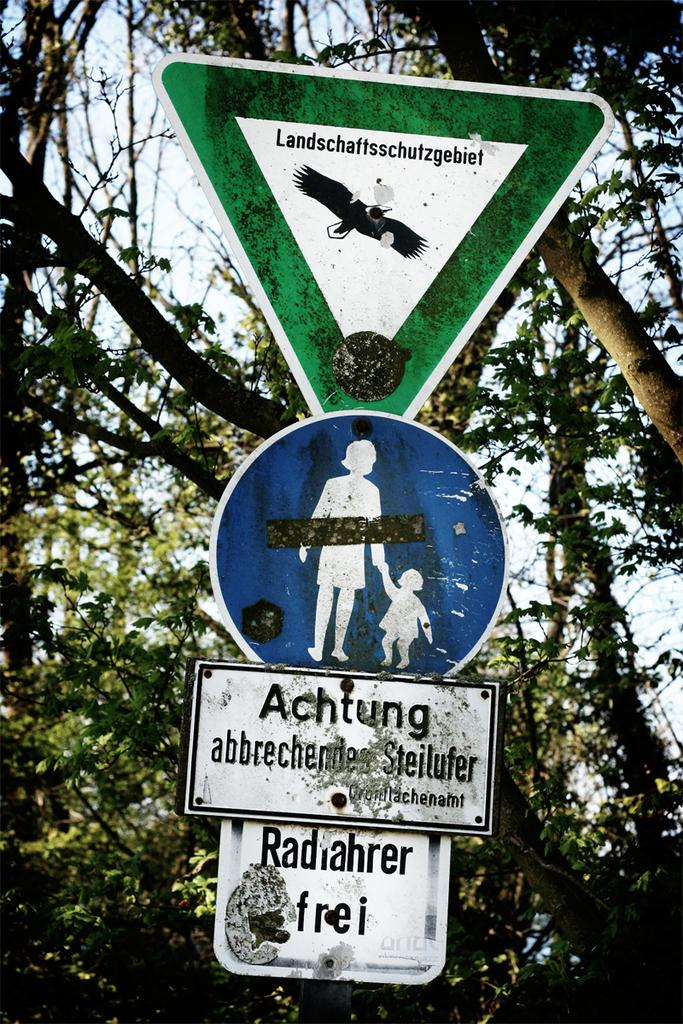What type of boards can be seen in the image? There are sign boards and name boards in the image. What can be found in the background of the image? There are trees and the sky visible in the background of the image. How many apples are hanging from the trees in the image? There are no apples present in the image; only trees can be seen in the background. 